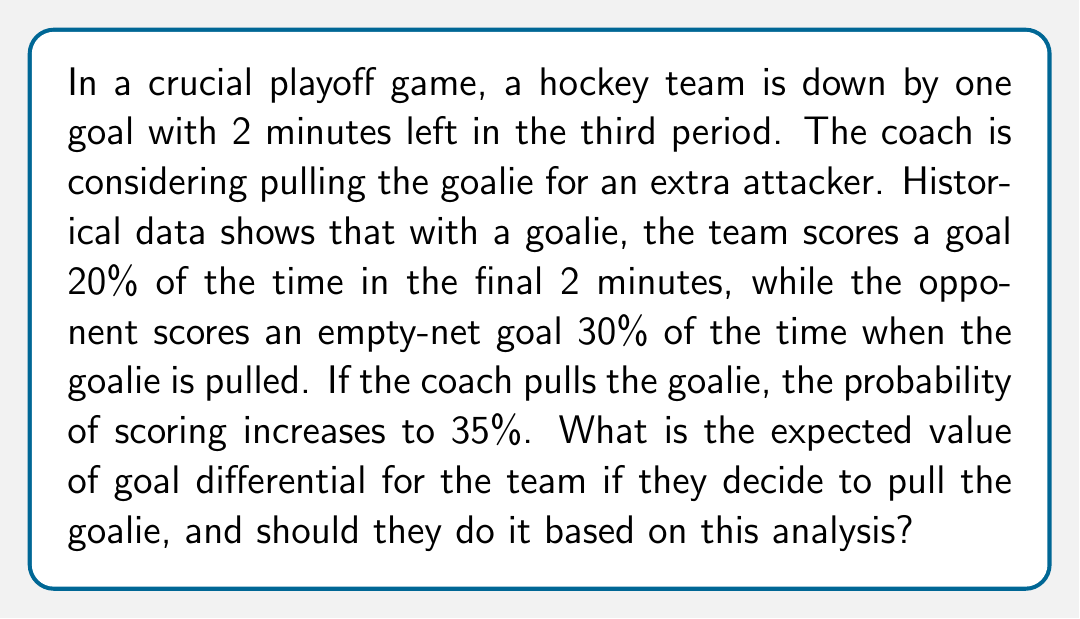Solve this math problem. Let's break this down step-by-step:

1) First, we need to calculate the expected goal differential for both scenarios: keeping the goalie in and pulling the goalie.

2) With the goalie in:
   - Probability of scoring: 20% = 0.2
   - Probability of opponent scoring: 0% (assuming the opponent won't score against a goalie in this short time)
   Expected goal differential: $0.2 \cdot 1 + 0 \cdot (-1) = 0.2$

3) With the goalie pulled:
   - Probability of scoring: 35% = 0.35
   - Probability of opponent scoring an empty-net goal: 30% = 0.3
   Expected goal differential: $0.35 \cdot 1 + 0.3 \cdot (-1) = 0.35 - 0.3 = 0.05$

4) To calculate the expected value of the goal differential when pulling the goalie, we use:

   $E(\text{Goal Differential}) = P(\text{Team Scores}) \cdot 1 + P(\text{Opponent Scores}) \cdot (-1)$

   $E(\text{Goal Differential}) = 0.35 \cdot 1 + 0.3 \cdot (-1) = 0.35 - 0.3 = 0.05$

5) Comparing the two scenarios:
   - Keeping the goalie in: Expected goal differential = 0.2
   - Pulling the goalie: Expected goal differential = 0.05

6) Based on this analysis, keeping the goalie in provides a higher expected goal differential (0.2 > 0.05).

However, it's important to note that this analysis doesn't account for the current score. Since the team is down by one goal, they need to score to tie the game. The probability of scoring is higher when the goalie is pulled (35% vs 20%), which might be more valuable in this specific scenario than the expected goal differential.
Answer: The expected value of goal differential for the team if they decide to pull the goalie is 0.05. Based solely on the expected goal differential, they should not pull the goalie. However, given that they need to score to tie the game, the increased probability of scoring with the goalie pulled (35% vs 20%) might outweigh the risk of conceding an empty-net goal in this specific scenario. 